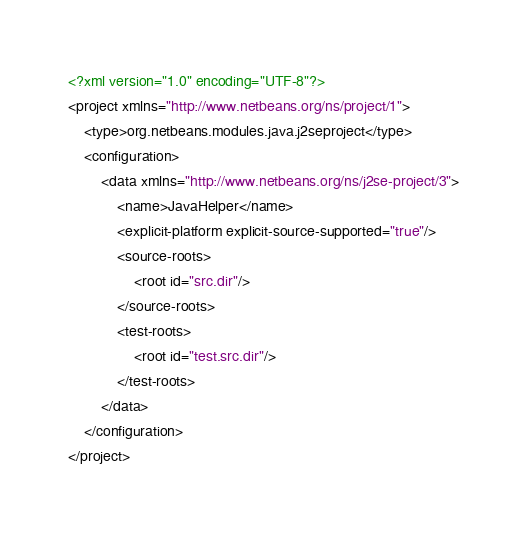<code> <loc_0><loc_0><loc_500><loc_500><_XML_><?xml version="1.0" encoding="UTF-8"?>
<project xmlns="http://www.netbeans.org/ns/project/1">
    <type>org.netbeans.modules.java.j2seproject</type>
    <configuration>
        <data xmlns="http://www.netbeans.org/ns/j2se-project/3">
            <name>JavaHelper</name>
            <explicit-platform explicit-source-supported="true"/>
            <source-roots>
                <root id="src.dir"/>
            </source-roots>
            <test-roots>
                <root id="test.src.dir"/>
            </test-roots>
        </data>
    </configuration>
</project>
</code> 